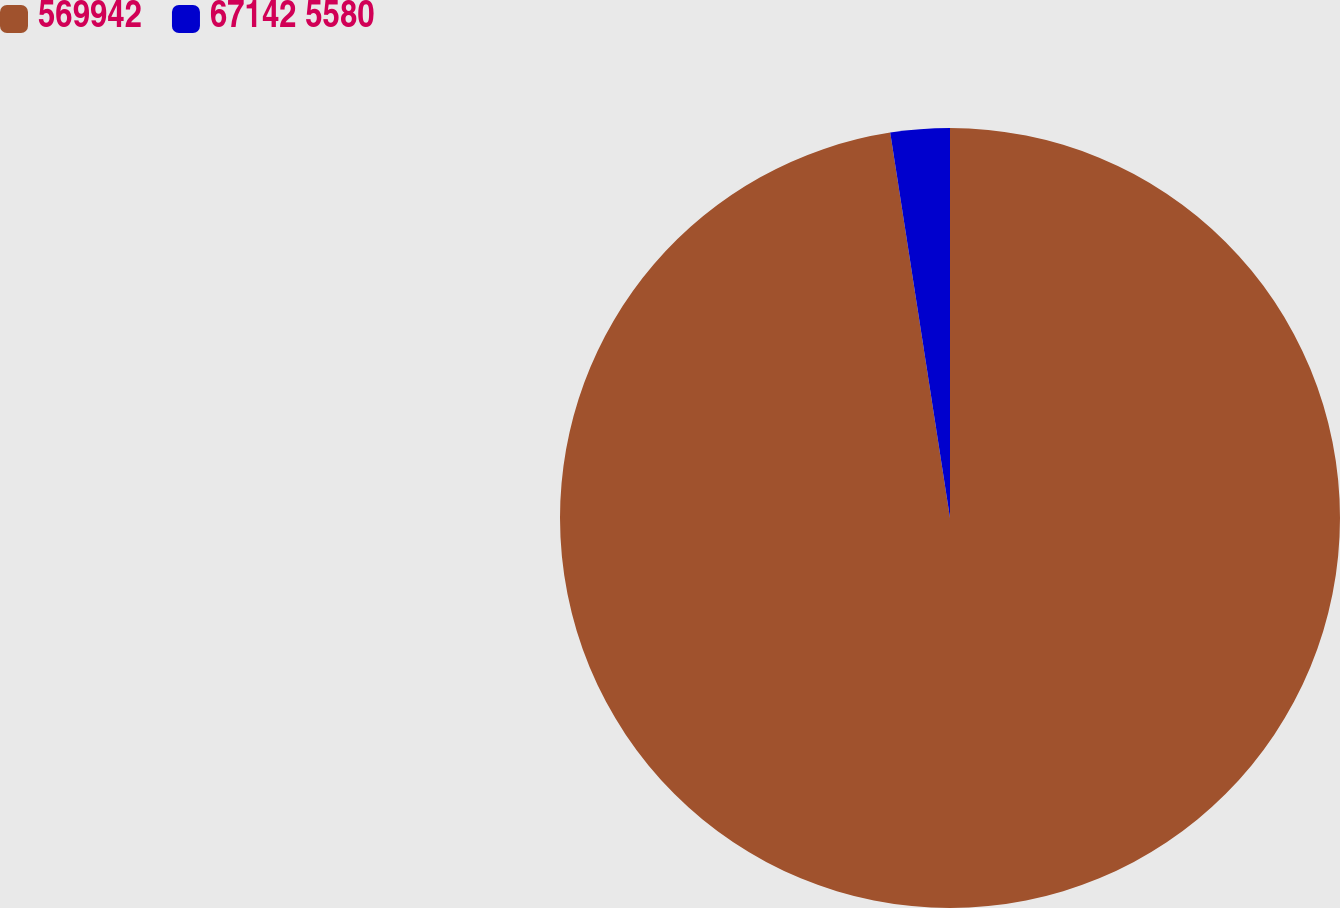<chart> <loc_0><loc_0><loc_500><loc_500><pie_chart><fcel>569942<fcel>67142 5580<nl><fcel>97.55%<fcel>2.45%<nl></chart> 